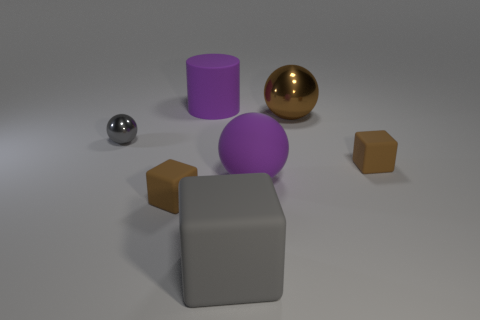Subtract all big rubber balls. How many balls are left? 2 Add 2 large purple rubber cylinders. How many objects exist? 9 Subtract all brown cubes. How many cubes are left? 1 Subtract all blocks. How many objects are left? 4 Subtract all blue blocks. Subtract all cyan spheres. How many blocks are left? 3 Subtract all red cylinders. How many green spheres are left? 0 Subtract all gray cubes. Subtract all big purple balls. How many objects are left? 5 Add 6 cylinders. How many cylinders are left? 7 Add 6 big gray cubes. How many big gray cubes exist? 7 Subtract 0 red cubes. How many objects are left? 7 